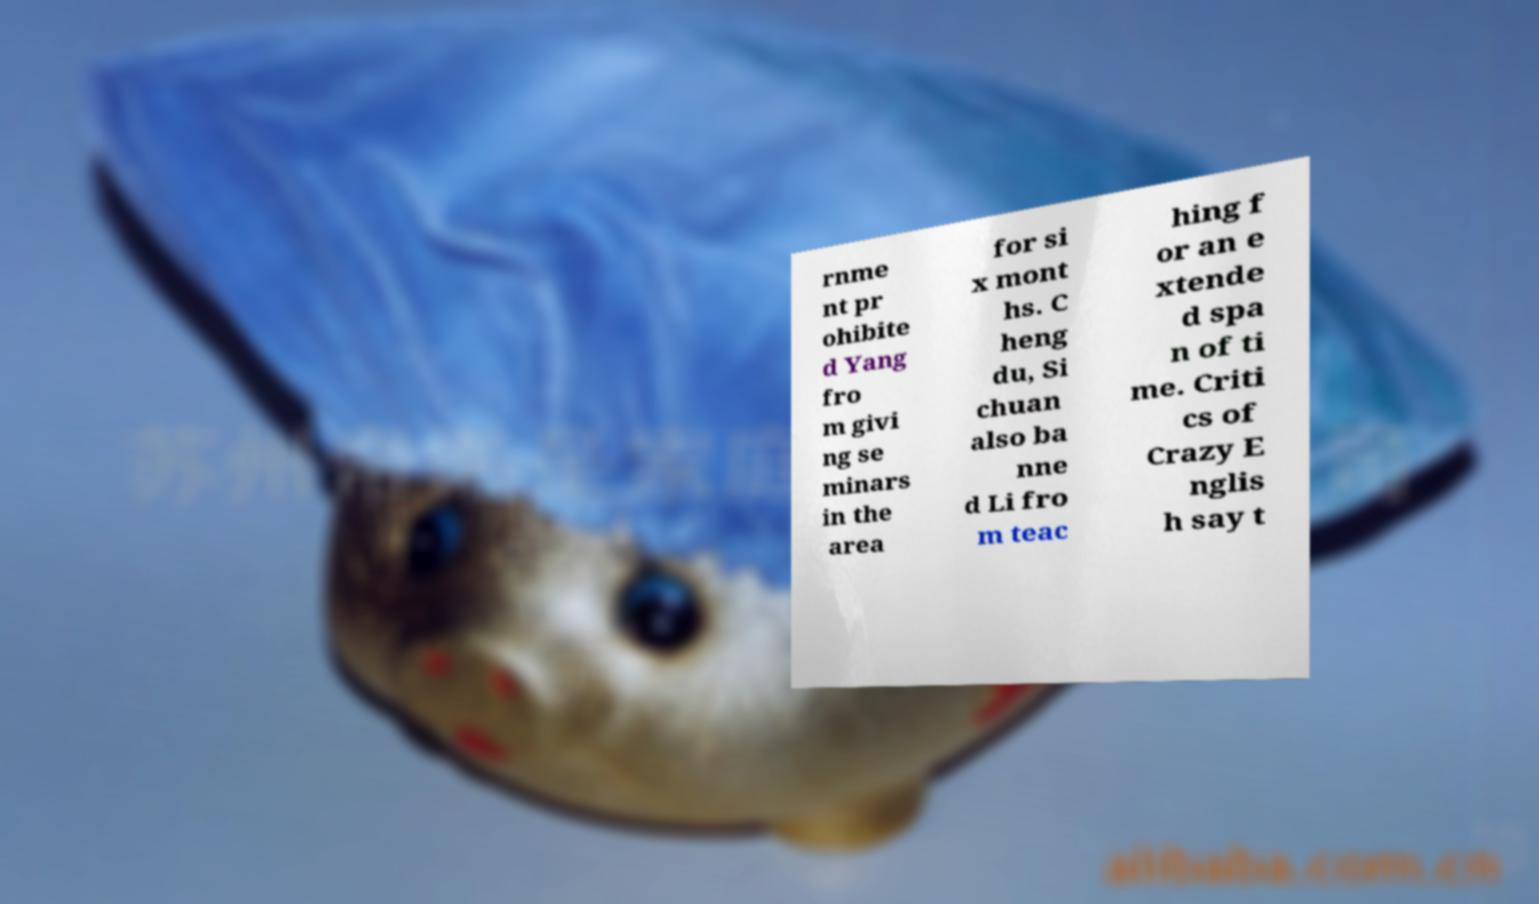There's text embedded in this image that I need extracted. Can you transcribe it verbatim? rnme nt pr ohibite d Yang fro m givi ng se minars in the area for si x mont hs. C heng du, Si chuan also ba nne d Li fro m teac hing f or an e xtende d spa n of ti me. Criti cs of Crazy E nglis h say t 